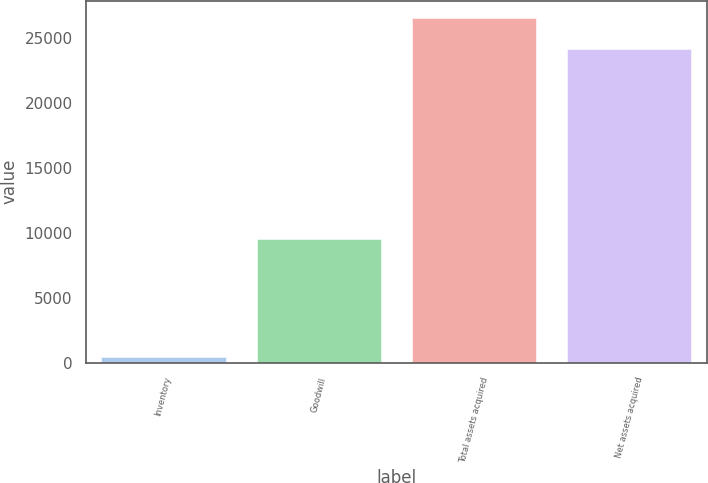<chart> <loc_0><loc_0><loc_500><loc_500><bar_chart><fcel>Inventory<fcel>Goodwill<fcel>Total assets acquired<fcel>Net assets acquired<nl><fcel>442<fcel>9575<fcel>26577.3<fcel>24180<nl></chart> 